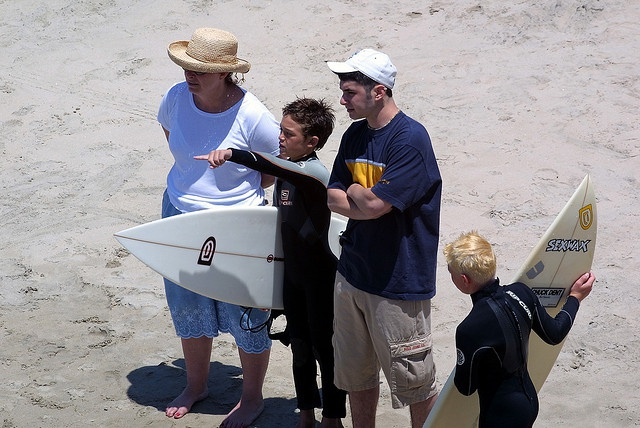Describe the objects in this image and their specific colors. I can see people in lightgray, black, gray, and navy tones, people in lightgray, gray, lavender, and black tones, people in lightgray, black, gray, darkgray, and maroon tones, people in lightgray, black, gray, and maroon tones, and surfboard in lightgray and darkgray tones in this image. 